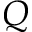Convert formula to latex. <formula><loc_0><loc_0><loc_500><loc_500>Q</formula> 